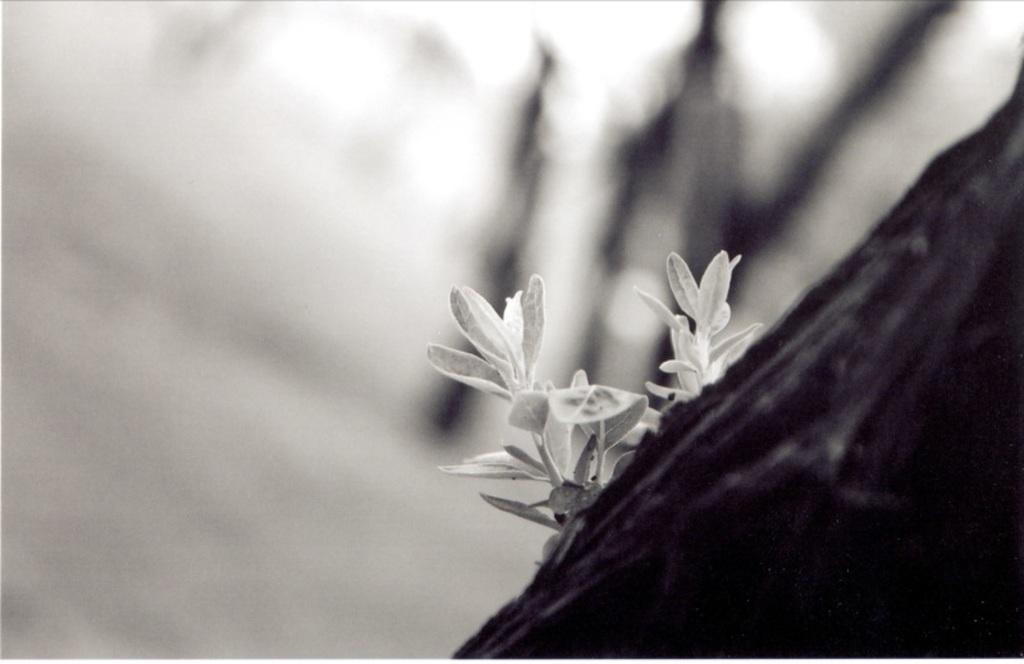Can you describe this image briefly? In this picture we can see leaves of a plant, there is a blurry background. 